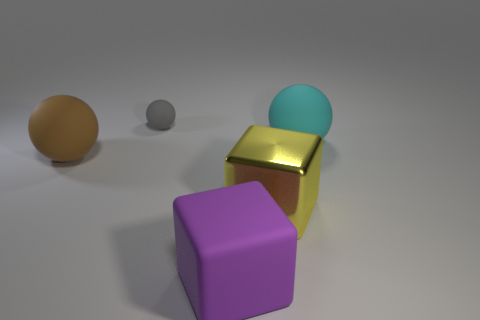There is a cyan sphere that is made of the same material as the gray thing; what size is it?
Offer a very short reply. Large. Are there fewer cyan matte objects than things?
Offer a terse response. Yes. What number of tiny objects are cyan objects or metal blocks?
Give a very brief answer. 0. What number of big spheres are left of the purple cube and on the right side of the tiny rubber thing?
Your response must be concise. 0. Are there more yellow metal objects than small red cylinders?
Your answer should be very brief. Yes. How many other objects are there of the same shape as the yellow thing?
Give a very brief answer. 1. What is the large object that is both behind the large yellow object and to the right of the small gray matte thing made of?
Offer a terse response. Rubber. The gray rubber ball is what size?
Give a very brief answer. Small. What number of large rubber spheres are in front of the large ball that is to the left of the rubber ball on the right side of the purple cube?
Give a very brief answer. 0. There is a matte object that is in front of the brown rubber sphere that is in front of the cyan sphere; what shape is it?
Ensure brevity in your answer.  Cube. 